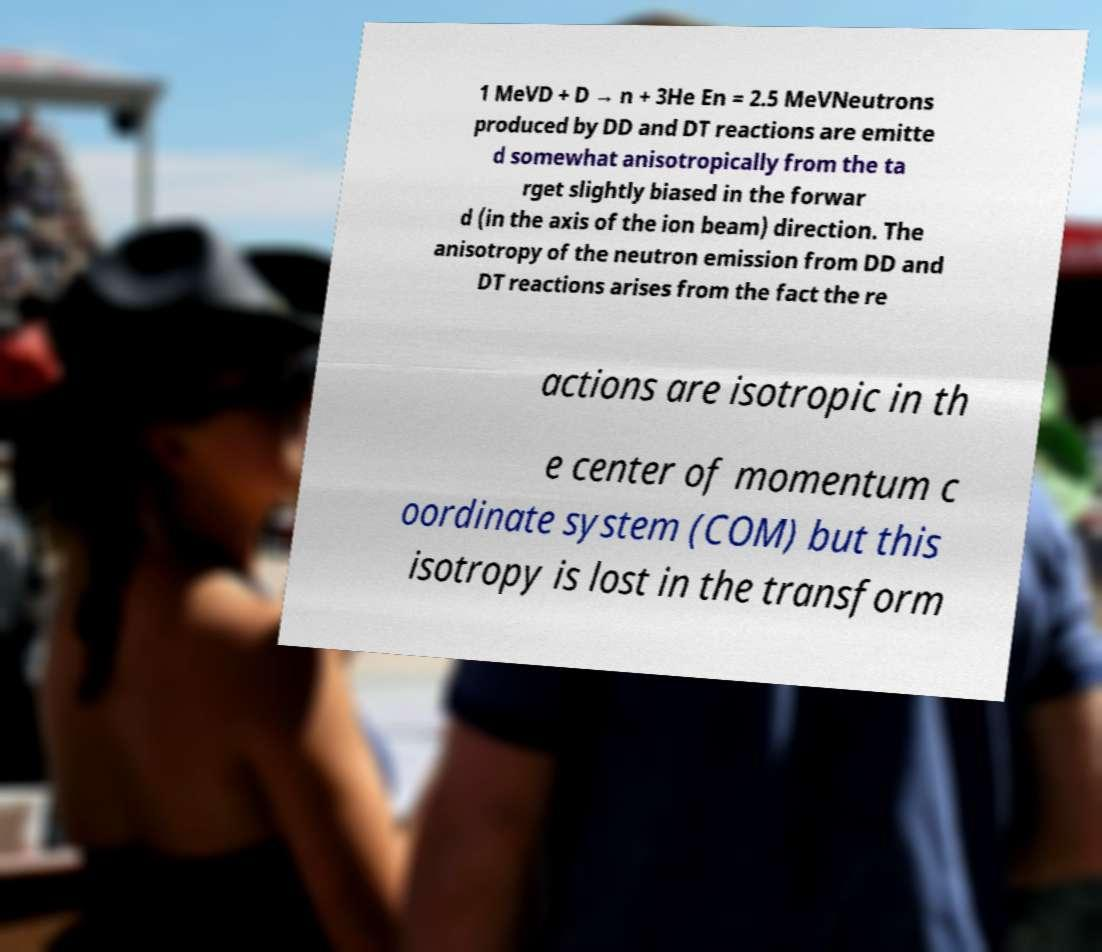What messages or text are displayed in this image? I need them in a readable, typed format. 1 MeVD + D → n + 3He En = 2.5 MeVNeutrons produced by DD and DT reactions are emitte d somewhat anisotropically from the ta rget slightly biased in the forwar d (in the axis of the ion beam) direction. The anisotropy of the neutron emission from DD and DT reactions arises from the fact the re actions are isotropic in th e center of momentum c oordinate system (COM) but this isotropy is lost in the transform 